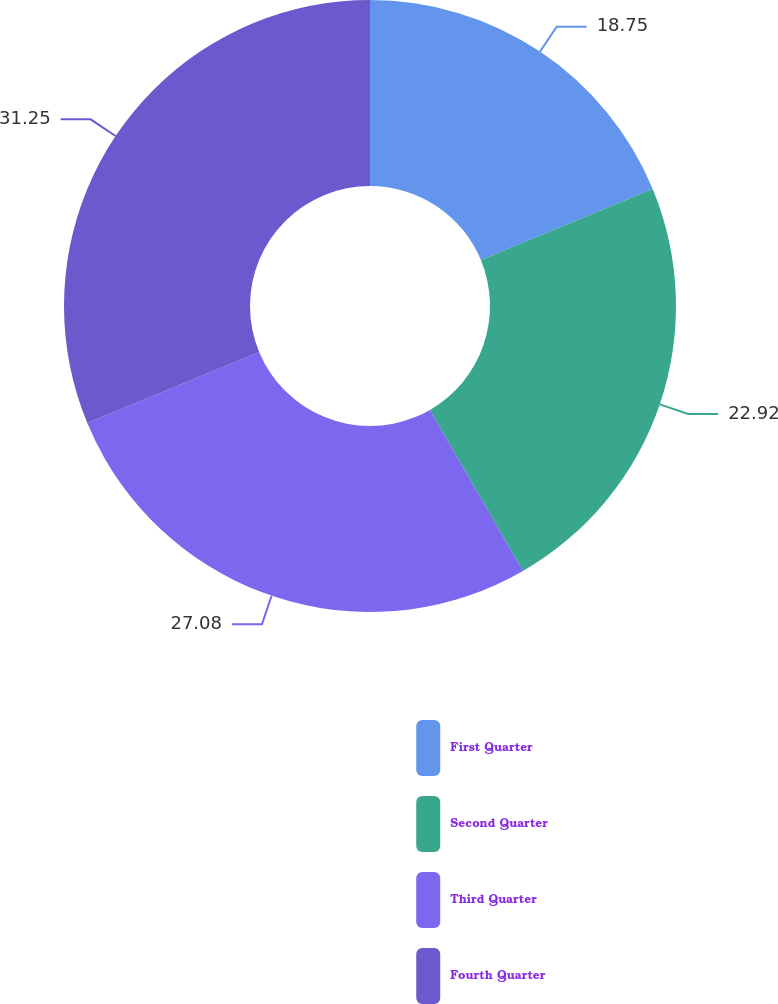<chart> <loc_0><loc_0><loc_500><loc_500><pie_chart><fcel>First Quarter<fcel>Second Quarter<fcel>Third Quarter<fcel>Fourth Quarter<nl><fcel>18.75%<fcel>22.92%<fcel>27.08%<fcel>31.25%<nl></chart> 